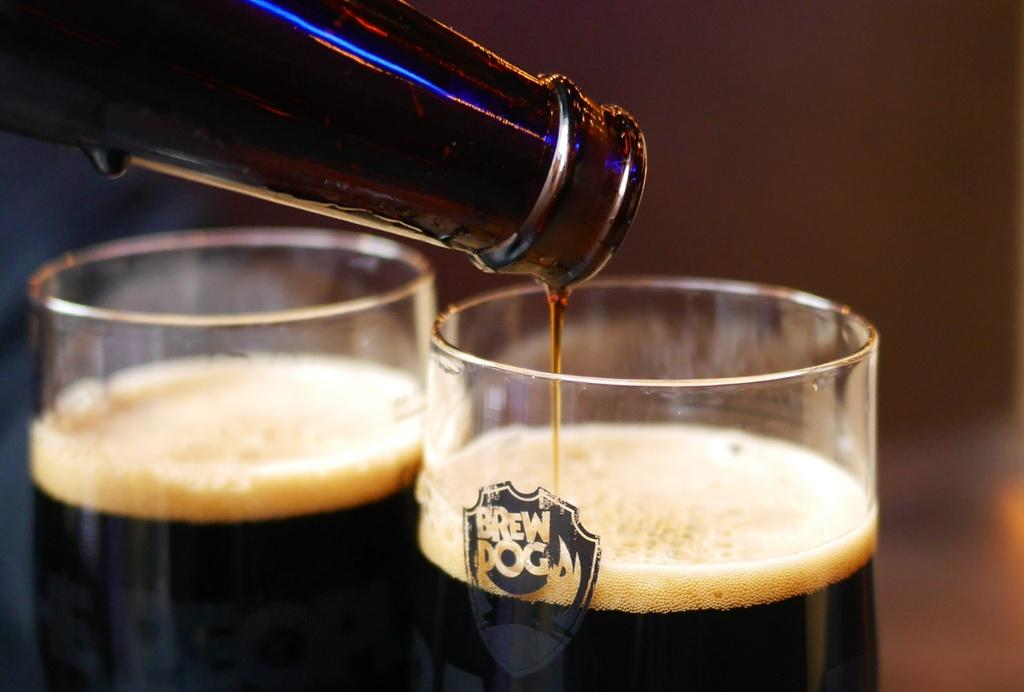How many glasses of drink are visible in the image? There are two glasses of drink in the image. What is the color of the drink in the glasses? The drink is black in color. How is the drink being served in the glasses? There is a bottle serving the drink in the glass. Can you see a guitar being played in the image? There is no guitar or any musical instrument visible in the image. Is there a nest with baby birds in the image? There is no nest or any reference to birds in the image. 